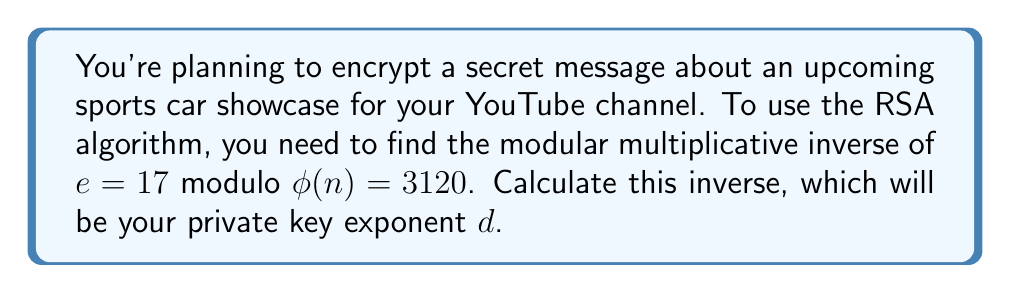Show me your answer to this math problem. To find the modular multiplicative inverse of 17 modulo 3120, we need to find a number $d$ such that:

$$(17 \cdot d) \equiv 1 \pmod{3120}$$

We can use the extended Euclidean algorithm to find this value:

1) First, apply the Euclidean algorithm:
   
   $3120 = 183 \cdot 17 + 9$
   $17 = 1 \cdot 9 + 8$
   $9 = 1 \cdot 8 + 1$
   $8 = 8 \cdot 1 + 0$

2) Now, work backwards to express 1 as a linear combination of 3120 and 17:

   $1 = 9 - 1 \cdot 8$
   $1 = 9 - 1 \cdot (17 - 1 \cdot 9) = 2 \cdot 9 - 1 \cdot 17$
   $1 = 2 \cdot (3120 - 183 \cdot 17) - 1 \cdot 17$
   $1 = 2 \cdot 3120 - 367 \cdot 17$

3) Therefore, $-367 \cdot 17 \equiv 1 \pmod{3120}$

4) To get a positive number between 0 and 3119, add 3120 to -367 until we get a positive number:
   
   $-367 + 3120 = 2753$

Thus, $2753 \cdot 17 \equiv 1 \pmod{3120}$, so $d = 2753$ is the modular multiplicative inverse of 17 modulo 3120.
Answer: $d = 2753$ 